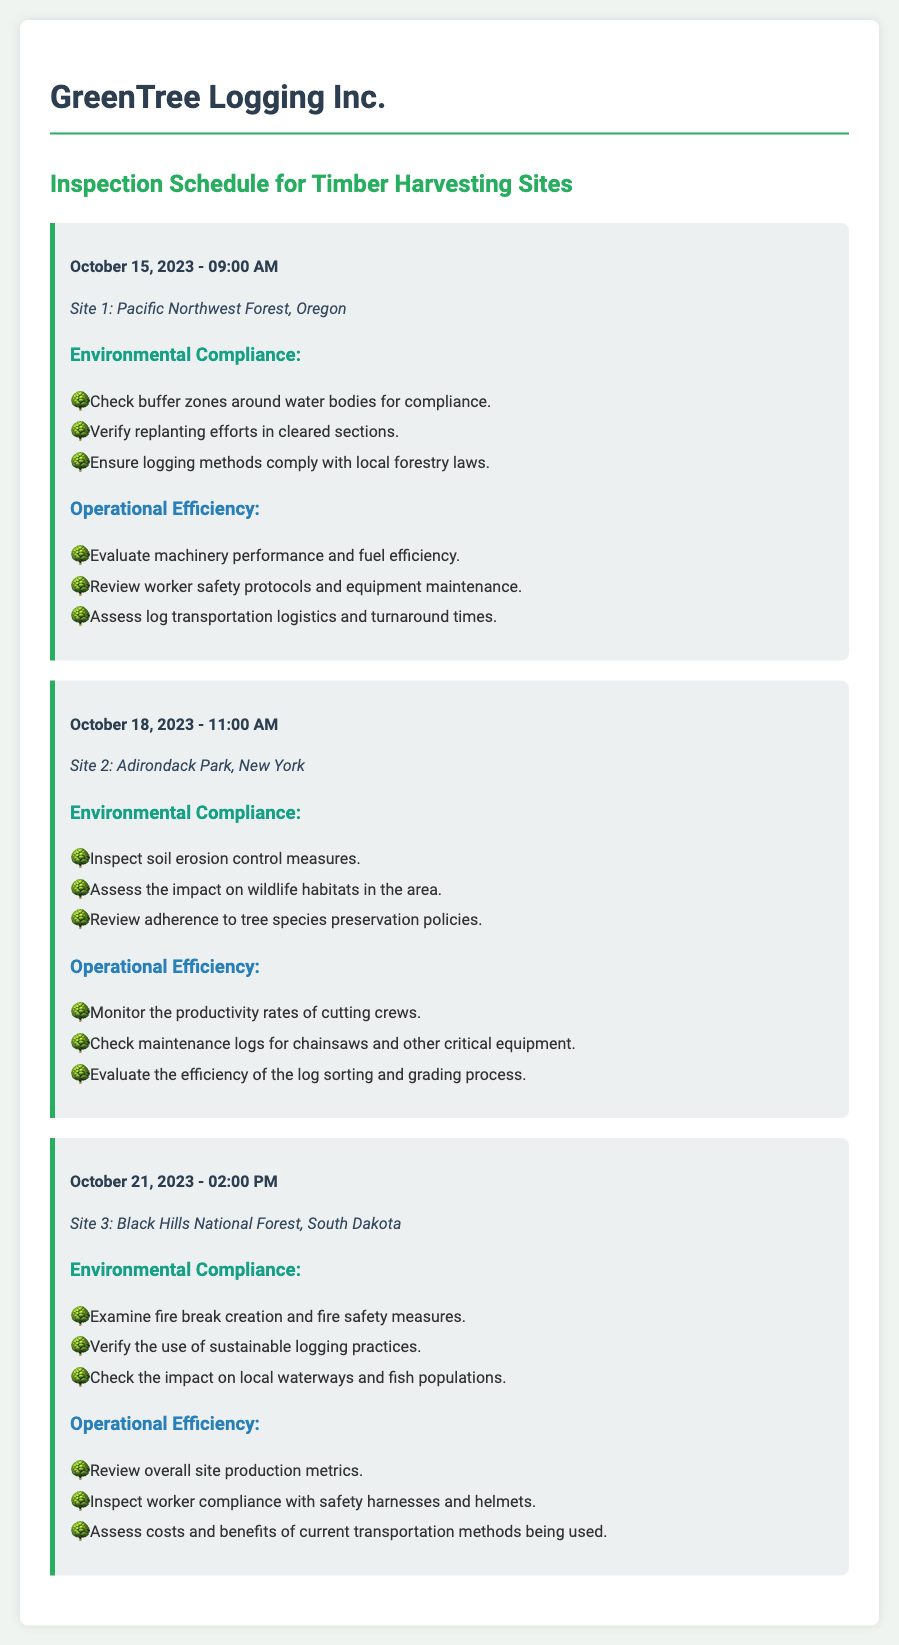What is the date and time of the inspection for Site 1? The date and time for Site 1 is listed in the document as October 15, 2023 - 09:00 AM.
Answer: October 15, 2023 - 09:00 AM Where is Site 2 located? The location for Site 2 is specified in the document as Adirondack Park, New York.
Answer: Adirondack Park, New York What is one of the measures checked for environmental compliance at Site 3? The document states specific measures for environmental compliance at Site 3, including examining fire break creation and fire safety measures.
Answer: Fire break creation How many inspections are scheduled in total? The document outlines three inspection schedules, each for a different location, indicating the total number of inspections.
Answer: 3 What equipment is monitored for maintenance at Site 2? The document mentions checking maintenance logs specifically for chainsaws and other critical equipment at Site 2.
Answer: Chainsaws Assessing log transportation logistics falls under which category? The document categorizes this evaluation as part of operational efficiency during the inspection of timber harvesting sites.
Answer: Operational Efficiency What environmental aspect is monitored during the inspection of Site 1? The document highlights checking buffer zones around water bodies as one of the environmental aspects monitored at Site 1.
Answer: Buffer zones When is the inspection for Site 3 scheduled? The date and time for Site 3's inspection are specified in the document as October 21, 2023 - 02:00 PM.
Answer: October 21, 2023 - 02:00 PM 